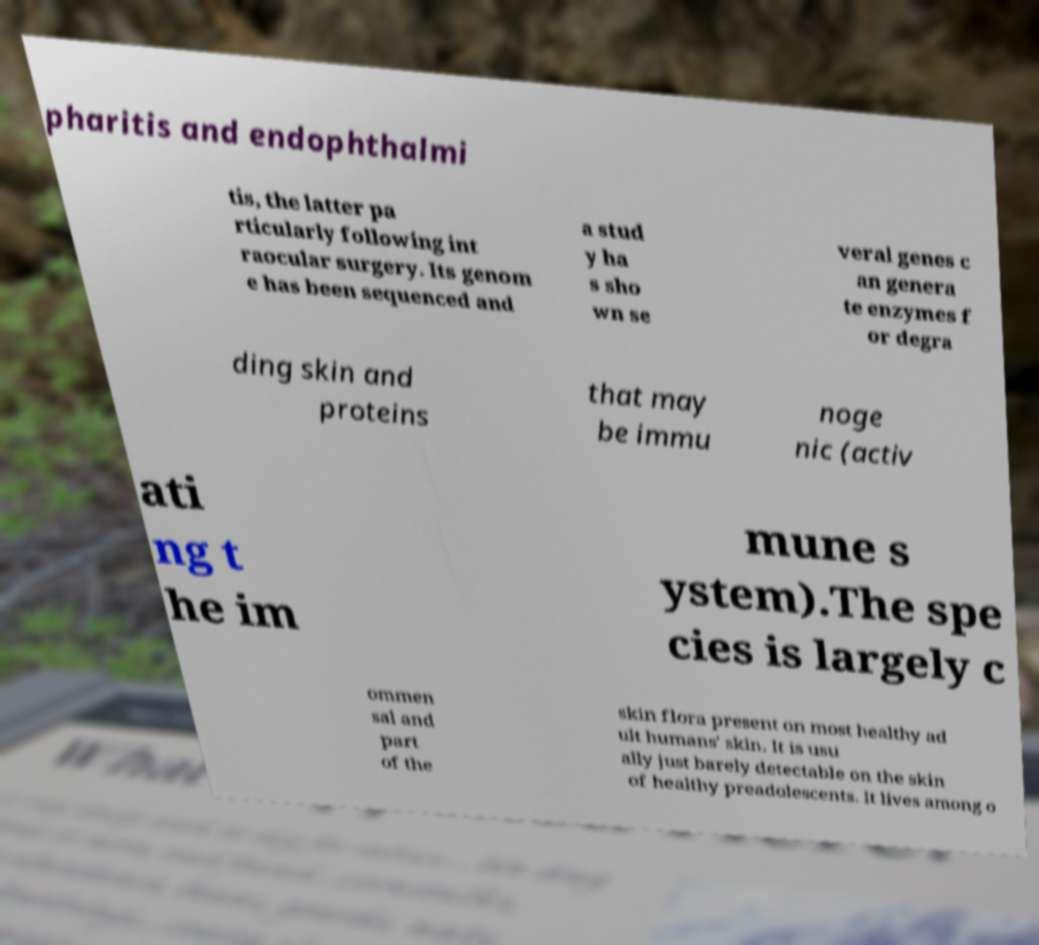There's text embedded in this image that I need extracted. Can you transcribe it verbatim? pharitis and endophthalmi tis, the latter pa rticularly following int raocular surgery. Its genom e has been sequenced and a stud y ha s sho wn se veral genes c an genera te enzymes f or degra ding skin and proteins that may be immu noge nic (activ ati ng t he im mune s ystem).The spe cies is largely c ommen sal and part of the skin flora present on most healthy ad ult humans' skin. It is usu ally just barely detectable on the skin of healthy preadolescents. It lives among o 